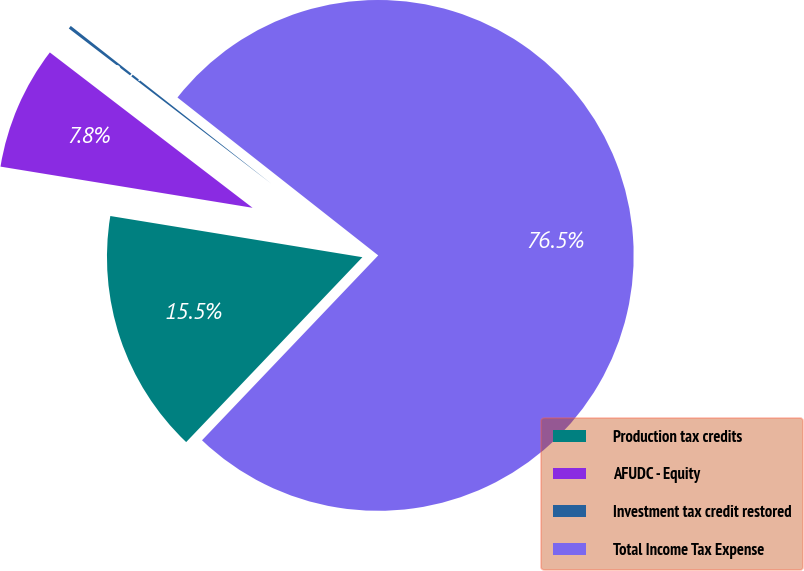Convert chart. <chart><loc_0><loc_0><loc_500><loc_500><pie_chart><fcel>Production tax credits<fcel>AFUDC - Equity<fcel>Investment tax credit restored<fcel>Total Income Tax Expense<nl><fcel>15.46%<fcel>7.83%<fcel>0.2%<fcel>76.51%<nl></chart> 